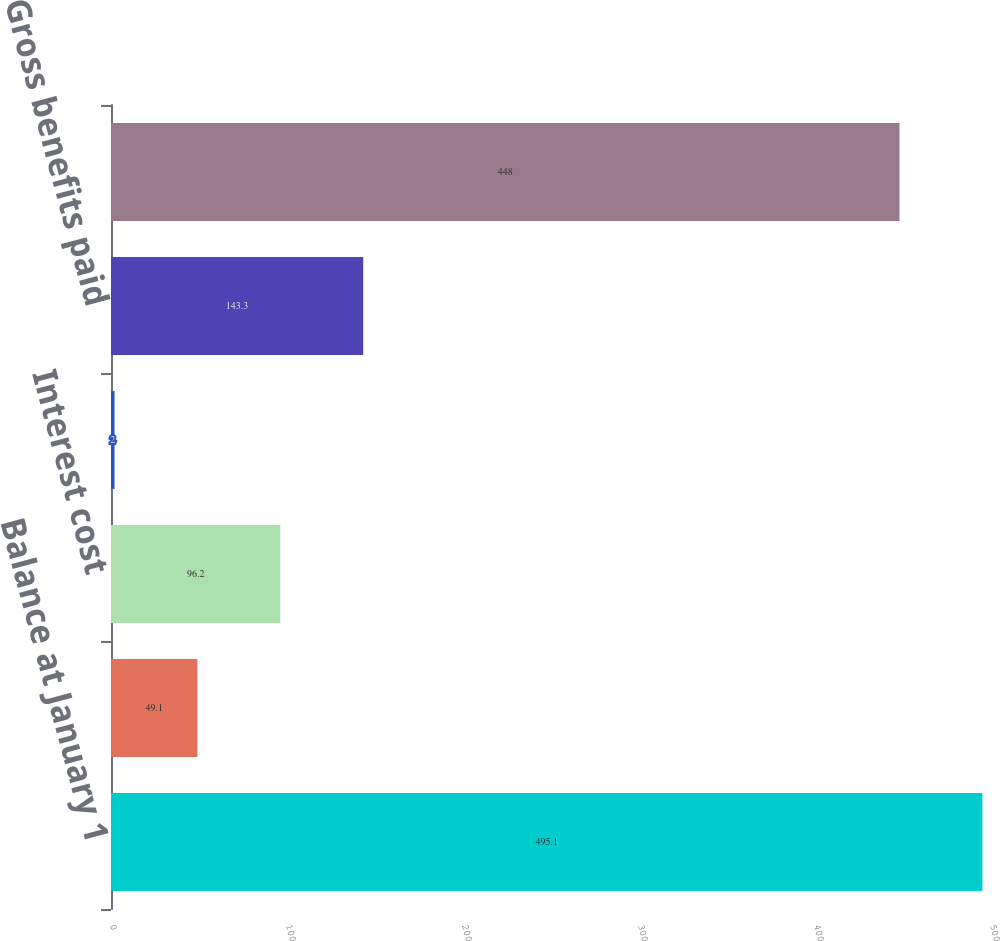Convert chart. <chart><loc_0><loc_0><loc_500><loc_500><bar_chart><fcel>Balance at January 1<fcel>Service cost<fcel>Interest cost<fcel>Actuarial (gain) loss<fcel>Gross benefits paid<fcel>Balance at December 31<nl><fcel>495.1<fcel>49.1<fcel>96.2<fcel>2<fcel>143.3<fcel>448<nl></chart> 